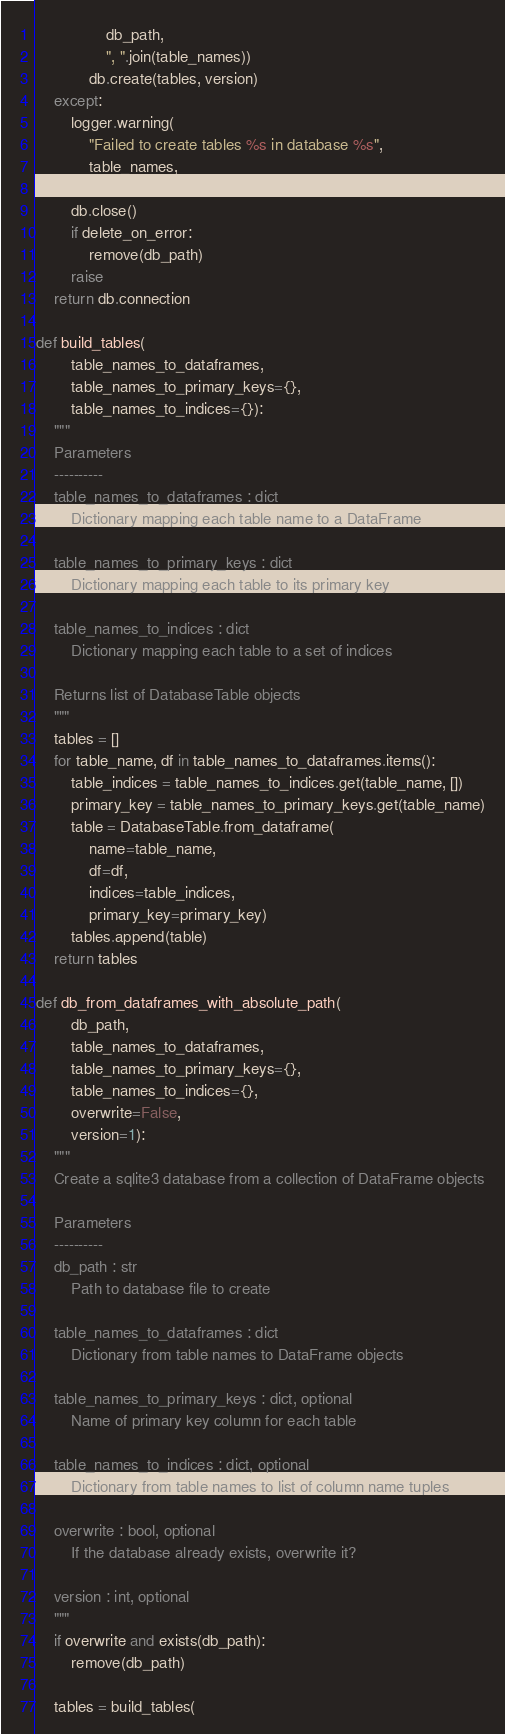Convert code to text. <code><loc_0><loc_0><loc_500><loc_500><_Python_>                db_path,
                ", ".join(table_names))
            db.create(tables, version)
    except:
        logger.warning(
            "Failed to create tables %s in database %s",
            table_names,
            db_path)
        db.close()
        if delete_on_error:
            remove(db_path)
        raise
    return db.connection

def build_tables(
        table_names_to_dataframes,
        table_names_to_primary_keys={},
        table_names_to_indices={}):
    """
    Parameters
    ----------
    table_names_to_dataframes : dict
        Dictionary mapping each table name to a DataFrame

    table_names_to_primary_keys : dict
        Dictionary mapping each table to its primary key

    table_names_to_indices : dict
        Dictionary mapping each table to a set of indices

    Returns list of DatabaseTable objects
    """
    tables = []
    for table_name, df in table_names_to_dataframes.items():
        table_indices = table_names_to_indices.get(table_name, [])
        primary_key = table_names_to_primary_keys.get(table_name)
        table = DatabaseTable.from_dataframe(
            name=table_name,
            df=df,
            indices=table_indices,
            primary_key=primary_key)
        tables.append(table)
    return tables

def db_from_dataframes_with_absolute_path(
        db_path,
        table_names_to_dataframes,
        table_names_to_primary_keys={},
        table_names_to_indices={},
        overwrite=False,
        version=1):
    """
    Create a sqlite3 database from a collection of DataFrame objects

    Parameters
    ----------
    db_path : str
        Path to database file to create

    table_names_to_dataframes : dict
        Dictionary from table names to DataFrame objects

    table_names_to_primary_keys : dict, optional
        Name of primary key column for each table

    table_names_to_indices : dict, optional
        Dictionary from table names to list of column name tuples

    overwrite : bool, optional
        If the database already exists, overwrite it?

    version : int, optional
    """
    if overwrite and exists(db_path):
        remove(db_path)

    tables = build_tables(</code> 